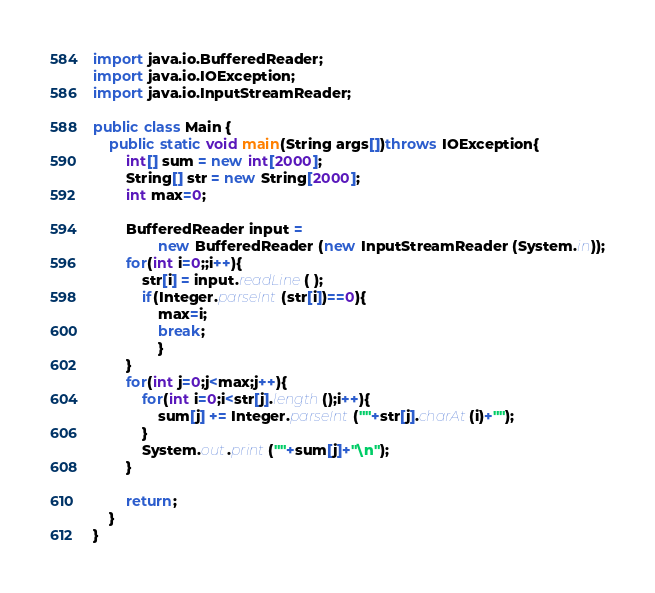Convert code to text. <code><loc_0><loc_0><loc_500><loc_500><_Java_>import java.io.BufferedReader;
import java.io.IOException;
import java.io.InputStreamReader;

public class Main {
	public static void main(String args[])throws IOException{
		int[] sum = new int[2000];
		String[] str = new String[2000];
		int max=0;
		
        BufferedReader input =
                new BufferedReader (new InputStreamReader (System.in));
        for(int i=0;;i++){
	        str[i] = input.readLine( );
	        if(Integer.parseInt(str[i])==0){
	        	max=i;
	        	break;
	        	}
        }
        for(int j=0;j<max;j++){
	        for(int i=0;i<str[j].length();i++){
	        	sum[j] += Integer.parseInt(""+str[j].charAt(i)+"");
	        }
        	System.out.print(""+sum[j]+"\n");
		}

        return;
	}
}</code> 